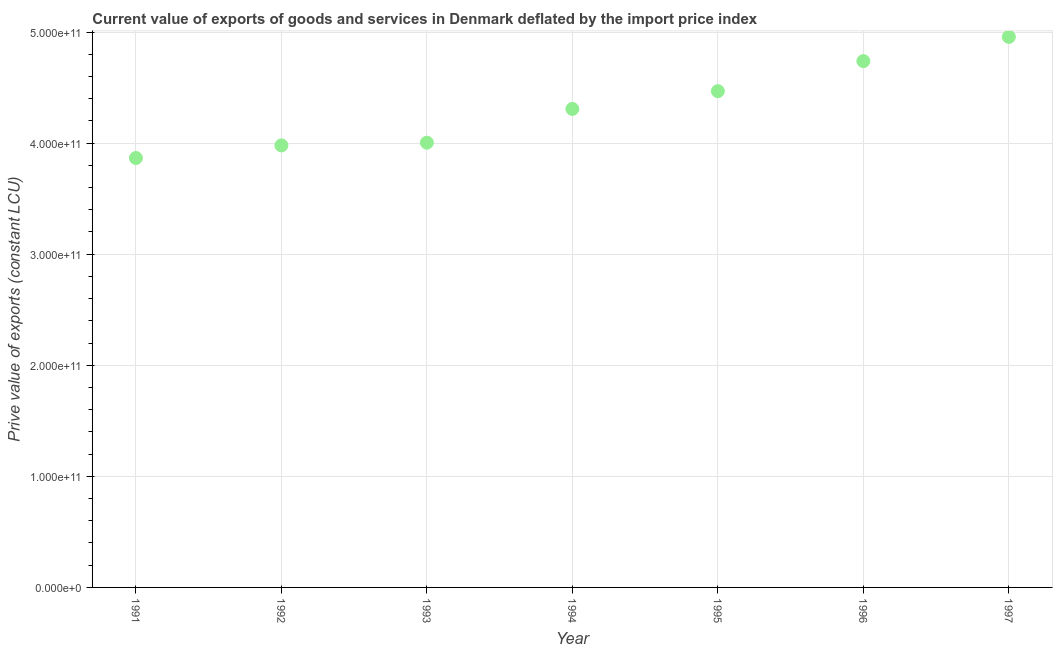What is the price value of exports in 1994?
Provide a succinct answer. 4.31e+11. Across all years, what is the maximum price value of exports?
Give a very brief answer. 4.96e+11. Across all years, what is the minimum price value of exports?
Offer a terse response. 3.87e+11. What is the sum of the price value of exports?
Ensure brevity in your answer.  3.03e+12. What is the difference between the price value of exports in 1994 and 1996?
Offer a very short reply. -4.31e+1. What is the average price value of exports per year?
Your answer should be compact. 4.33e+11. What is the median price value of exports?
Offer a terse response. 4.31e+11. What is the ratio of the price value of exports in 1992 to that in 1994?
Your answer should be very brief. 0.92. What is the difference between the highest and the second highest price value of exports?
Ensure brevity in your answer.  2.18e+1. Is the sum of the price value of exports in 1991 and 1996 greater than the maximum price value of exports across all years?
Ensure brevity in your answer.  Yes. What is the difference between the highest and the lowest price value of exports?
Offer a very short reply. 1.09e+11. In how many years, is the price value of exports greater than the average price value of exports taken over all years?
Your answer should be compact. 3. Does the price value of exports monotonically increase over the years?
Offer a very short reply. Yes. How many dotlines are there?
Offer a very short reply. 1. What is the difference between two consecutive major ticks on the Y-axis?
Your answer should be very brief. 1.00e+11. Are the values on the major ticks of Y-axis written in scientific E-notation?
Ensure brevity in your answer.  Yes. Does the graph contain any zero values?
Keep it short and to the point. No. Does the graph contain grids?
Provide a succinct answer. Yes. What is the title of the graph?
Give a very brief answer. Current value of exports of goods and services in Denmark deflated by the import price index. What is the label or title of the Y-axis?
Keep it short and to the point. Prive value of exports (constant LCU). What is the Prive value of exports (constant LCU) in 1991?
Give a very brief answer. 3.87e+11. What is the Prive value of exports (constant LCU) in 1992?
Ensure brevity in your answer.  3.98e+11. What is the Prive value of exports (constant LCU) in 1993?
Your response must be concise. 4.00e+11. What is the Prive value of exports (constant LCU) in 1994?
Keep it short and to the point. 4.31e+11. What is the Prive value of exports (constant LCU) in 1995?
Your answer should be compact. 4.47e+11. What is the Prive value of exports (constant LCU) in 1996?
Offer a very short reply. 4.74e+11. What is the Prive value of exports (constant LCU) in 1997?
Provide a succinct answer. 4.96e+11. What is the difference between the Prive value of exports (constant LCU) in 1991 and 1992?
Make the answer very short. -1.13e+1. What is the difference between the Prive value of exports (constant LCU) in 1991 and 1993?
Keep it short and to the point. -1.38e+1. What is the difference between the Prive value of exports (constant LCU) in 1991 and 1994?
Your response must be concise. -4.42e+1. What is the difference between the Prive value of exports (constant LCU) in 1991 and 1995?
Ensure brevity in your answer.  -6.02e+1. What is the difference between the Prive value of exports (constant LCU) in 1991 and 1996?
Your answer should be very brief. -8.73e+1. What is the difference between the Prive value of exports (constant LCU) in 1991 and 1997?
Keep it short and to the point. -1.09e+11. What is the difference between the Prive value of exports (constant LCU) in 1992 and 1993?
Provide a succinct answer. -2.46e+09. What is the difference between the Prive value of exports (constant LCU) in 1992 and 1994?
Offer a terse response. -3.28e+1. What is the difference between the Prive value of exports (constant LCU) in 1992 and 1995?
Your answer should be very brief. -4.88e+1. What is the difference between the Prive value of exports (constant LCU) in 1992 and 1996?
Your answer should be very brief. -7.59e+1. What is the difference between the Prive value of exports (constant LCU) in 1992 and 1997?
Provide a short and direct response. -9.77e+1. What is the difference between the Prive value of exports (constant LCU) in 1993 and 1994?
Provide a short and direct response. -3.04e+1. What is the difference between the Prive value of exports (constant LCU) in 1993 and 1995?
Ensure brevity in your answer.  -4.64e+1. What is the difference between the Prive value of exports (constant LCU) in 1993 and 1996?
Keep it short and to the point. -7.34e+1. What is the difference between the Prive value of exports (constant LCU) in 1993 and 1997?
Offer a very short reply. -9.52e+1. What is the difference between the Prive value of exports (constant LCU) in 1994 and 1995?
Your answer should be compact. -1.60e+1. What is the difference between the Prive value of exports (constant LCU) in 1994 and 1996?
Your answer should be very brief. -4.31e+1. What is the difference between the Prive value of exports (constant LCU) in 1994 and 1997?
Offer a terse response. -6.49e+1. What is the difference between the Prive value of exports (constant LCU) in 1995 and 1996?
Your response must be concise. -2.71e+1. What is the difference between the Prive value of exports (constant LCU) in 1995 and 1997?
Offer a terse response. -4.89e+1. What is the difference between the Prive value of exports (constant LCU) in 1996 and 1997?
Offer a terse response. -2.18e+1. What is the ratio of the Prive value of exports (constant LCU) in 1991 to that in 1992?
Make the answer very short. 0.97. What is the ratio of the Prive value of exports (constant LCU) in 1991 to that in 1994?
Offer a very short reply. 0.9. What is the ratio of the Prive value of exports (constant LCU) in 1991 to that in 1995?
Your response must be concise. 0.86. What is the ratio of the Prive value of exports (constant LCU) in 1991 to that in 1996?
Provide a short and direct response. 0.82. What is the ratio of the Prive value of exports (constant LCU) in 1991 to that in 1997?
Provide a short and direct response. 0.78. What is the ratio of the Prive value of exports (constant LCU) in 1992 to that in 1993?
Your response must be concise. 0.99. What is the ratio of the Prive value of exports (constant LCU) in 1992 to that in 1994?
Provide a short and direct response. 0.92. What is the ratio of the Prive value of exports (constant LCU) in 1992 to that in 1995?
Ensure brevity in your answer.  0.89. What is the ratio of the Prive value of exports (constant LCU) in 1992 to that in 1996?
Your response must be concise. 0.84. What is the ratio of the Prive value of exports (constant LCU) in 1992 to that in 1997?
Make the answer very short. 0.8. What is the ratio of the Prive value of exports (constant LCU) in 1993 to that in 1994?
Offer a very short reply. 0.93. What is the ratio of the Prive value of exports (constant LCU) in 1993 to that in 1995?
Provide a short and direct response. 0.9. What is the ratio of the Prive value of exports (constant LCU) in 1993 to that in 1996?
Your response must be concise. 0.84. What is the ratio of the Prive value of exports (constant LCU) in 1993 to that in 1997?
Keep it short and to the point. 0.81. What is the ratio of the Prive value of exports (constant LCU) in 1994 to that in 1995?
Make the answer very short. 0.96. What is the ratio of the Prive value of exports (constant LCU) in 1994 to that in 1996?
Your response must be concise. 0.91. What is the ratio of the Prive value of exports (constant LCU) in 1994 to that in 1997?
Your response must be concise. 0.87. What is the ratio of the Prive value of exports (constant LCU) in 1995 to that in 1996?
Ensure brevity in your answer.  0.94. What is the ratio of the Prive value of exports (constant LCU) in 1995 to that in 1997?
Provide a short and direct response. 0.9. What is the ratio of the Prive value of exports (constant LCU) in 1996 to that in 1997?
Offer a very short reply. 0.96. 